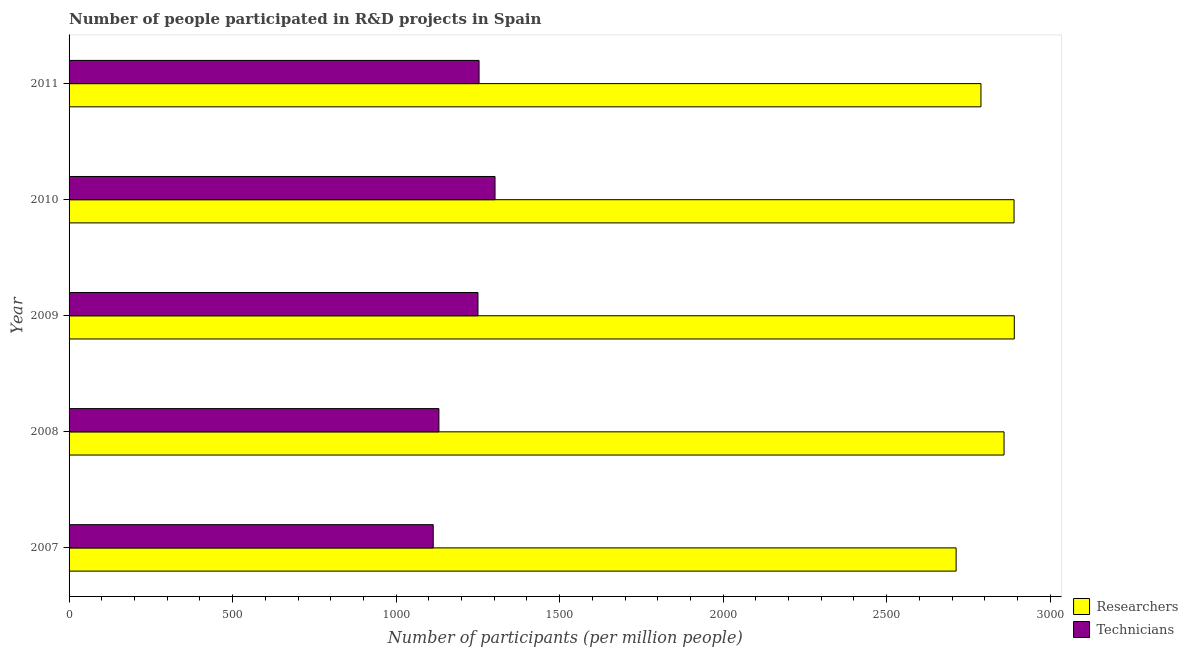Are the number of bars per tick equal to the number of legend labels?
Your response must be concise. Yes. What is the label of the 1st group of bars from the top?
Your answer should be compact. 2011. What is the number of technicians in 2011?
Your answer should be compact. 1253.62. Across all years, what is the maximum number of technicians?
Provide a succinct answer. 1302.46. Across all years, what is the minimum number of technicians?
Your response must be concise. 1113.5. What is the total number of researchers in the graph?
Provide a succinct answer. 1.41e+04. What is the difference between the number of researchers in 2008 and that in 2010?
Keep it short and to the point. -30.56. What is the difference between the number of researchers in 2009 and the number of technicians in 2007?
Ensure brevity in your answer.  1776.72. What is the average number of researchers per year?
Make the answer very short. 2827.84. In the year 2008, what is the difference between the number of researchers and number of technicians?
Offer a very short reply. 1728.05. In how many years, is the number of technicians greater than 1600 ?
Ensure brevity in your answer.  0. What is the ratio of the number of researchers in 2007 to that in 2010?
Your answer should be very brief. 0.94. Is the number of technicians in 2010 less than that in 2011?
Ensure brevity in your answer.  No. Is the difference between the number of researchers in 2007 and 2011 greater than the difference between the number of technicians in 2007 and 2011?
Keep it short and to the point. Yes. What is the difference between the highest and the second highest number of researchers?
Offer a terse response. 0.77. What is the difference between the highest and the lowest number of researchers?
Give a very brief answer. 177.87. Is the sum of the number of researchers in 2008 and 2009 greater than the maximum number of technicians across all years?
Give a very brief answer. Yes. What does the 2nd bar from the top in 2009 represents?
Your response must be concise. Researchers. What does the 2nd bar from the bottom in 2010 represents?
Give a very brief answer. Technicians. How many bars are there?
Your answer should be compact. 10. Are all the bars in the graph horizontal?
Provide a succinct answer. Yes. Are the values on the major ticks of X-axis written in scientific E-notation?
Offer a terse response. No. Does the graph contain any zero values?
Ensure brevity in your answer.  No. Does the graph contain grids?
Provide a short and direct response. No. What is the title of the graph?
Make the answer very short. Number of people participated in R&D projects in Spain. Does "Female" appear as one of the legend labels in the graph?
Keep it short and to the point. No. What is the label or title of the X-axis?
Give a very brief answer. Number of participants (per million people). What is the Number of participants (per million people) in Researchers in 2007?
Give a very brief answer. 2712.35. What is the Number of participants (per million people) of Technicians in 2007?
Provide a succinct answer. 1113.5. What is the Number of participants (per million people) in Researchers in 2008?
Give a very brief answer. 2858.9. What is the Number of participants (per million people) of Technicians in 2008?
Offer a very short reply. 1130.85. What is the Number of participants (per million people) of Researchers in 2009?
Offer a terse response. 2890.22. What is the Number of participants (per million people) in Technicians in 2009?
Your answer should be very brief. 1250.31. What is the Number of participants (per million people) in Researchers in 2010?
Provide a succinct answer. 2889.46. What is the Number of participants (per million people) of Technicians in 2010?
Keep it short and to the point. 1302.46. What is the Number of participants (per million people) in Researchers in 2011?
Make the answer very short. 2788.26. What is the Number of participants (per million people) in Technicians in 2011?
Offer a terse response. 1253.62. Across all years, what is the maximum Number of participants (per million people) in Researchers?
Your response must be concise. 2890.22. Across all years, what is the maximum Number of participants (per million people) of Technicians?
Offer a very short reply. 1302.46. Across all years, what is the minimum Number of participants (per million people) in Researchers?
Offer a very short reply. 2712.35. Across all years, what is the minimum Number of participants (per million people) in Technicians?
Your response must be concise. 1113.5. What is the total Number of participants (per million people) of Researchers in the graph?
Your answer should be compact. 1.41e+04. What is the total Number of participants (per million people) of Technicians in the graph?
Ensure brevity in your answer.  6050.74. What is the difference between the Number of participants (per million people) of Researchers in 2007 and that in 2008?
Make the answer very short. -146.55. What is the difference between the Number of participants (per million people) in Technicians in 2007 and that in 2008?
Your response must be concise. -17.35. What is the difference between the Number of participants (per million people) in Researchers in 2007 and that in 2009?
Offer a terse response. -177.87. What is the difference between the Number of participants (per million people) of Technicians in 2007 and that in 2009?
Your answer should be compact. -136.81. What is the difference between the Number of participants (per million people) of Researchers in 2007 and that in 2010?
Your answer should be very brief. -177.11. What is the difference between the Number of participants (per million people) of Technicians in 2007 and that in 2010?
Offer a very short reply. -188.96. What is the difference between the Number of participants (per million people) of Researchers in 2007 and that in 2011?
Offer a terse response. -75.91. What is the difference between the Number of participants (per million people) of Technicians in 2007 and that in 2011?
Your response must be concise. -140.12. What is the difference between the Number of participants (per million people) in Researchers in 2008 and that in 2009?
Keep it short and to the point. -31.32. What is the difference between the Number of participants (per million people) in Technicians in 2008 and that in 2009?
Your answer should be compact. -119.47. What is the difference between the Number of participants (per million people) of Researchers in 2008 and that in 2010?
Give a very brief answer. -30.56. What is the difference between the Number of participants (per million people) in Technicians in 2008 and that in 2010?
Make the answer very short. -171.61. What is the difference between the Number of participants (per million people) of Researchers in 2008 and that in 2011?
Your response must be concise. 70.64. What is the difference between the Number of participants (per million people) in Technicians in 2008 and that in 2011?
Offer a terse response. -122.77. What is the difference between the Number of participants (per million people) in Researchers in 2009 and that in 2010?
Ensure brevity in your answer.  0.77. What is the difference between the Number of participants (per million people) of Technicians in 2009 and that in 2010?
Your answer should be very brief. -52.15. What is the difference between the Number of participants (per million people) of Researchers in 2009 and that in 2011?
Your answer should be very brief. 101.97. What is the difference between the Number of participants (per million people) in Technicians in 2009 and that in 2011?
Your response must be concise. -3.31. What is the difference between the Number of participants (per million people) of Researchers in 2010 and that in 2011?
Your answer should be compact. 101.2. What is the difference between the Number of participants (per million people) in Technicians in 2010 and that in 2011?
Provide a succinct answer. 48.84. What is the difference between the Number of participants (per million people) of Researchers in 2007 and the Number of participants (per million people) of Technicians in 2008?
Ensure brevity in your answer.  1581.5. What is the difference between the Number of participants (per million people) of Researchers in 2007 and the Number of participants (per million people) of Technicians in 2009?
Ensure brevity in your answer.  1462.04. What is the difference between the Number of participants (per million people) in Researchers in 2007 and the Number of participants (per million people) in Technicians in 2010?
Provide a short and direct response. 1409.89. What is the difference between the Number of participants (per million people) of Researchers in 2007 and the Number of participants (per million people) of Technicians in 2011?
Ensure brevity in your answer.  1458.73. What is the difference between the Number of participants (per million people) in Researchers in 2008 and the Number of participants (per million people) in Technicians in 2009?
Your answer should be compact. 1608.59. What is the difference between the Number of participants (per million people) of Researchers in 2008 and the Number of participants (per million people) of Technicians in 2010?
Keep it short and to the point. 1556.44. What is the difference between the Number of participants (per million people) in Researchers in 2008 and the Number of participants (per million people) in Technicians in 2011?
Provide a short and direct response. 1605.28. What is the difference between the Number of participants (per million people) of Researchers in 2009 and the Number of participants (per million people) of Technicians in 2010?
Keep it short and to the point. 1587.76. What is the difference between the Number of participants (per million people) of Researchers in 2009 and the Number of participants (per million people) of Technicians in 2011?
Your answer should be very brief. 1636.6. What is the difference between the Number of participants (per million people) in Researchers in 2010 and the Number of participants (per million people) in Technicians in 2011?
Keep it short and to the point. 1635.84. What is the average Number of participants (per million people) of Researchers per year?
Provide a succinct answer. 2827.84. What is the average Number of participants (per million people) of Technicians per year?
Your answer should be compact. 1210.15. In the year 2007, what is the difference between the Number of participants (per million people) in Researchers and Number of participants (per million people) in Technicians?
Make the answer very short. 1598.85. In the year 2008, what is the difference between the Number of participants (per million people) in Researchers and Number of participants (per million people) in Technicians?
Provide a succinct answer. 1728.05. In the year 2009, what is the difference between the Number of participants (per million people) in Researchers and Number of participants (per million people) in Technicians?
Provide a succinct answer. 1639.91. In the year 2010, what is the difference between the Number of participants (per million people) in Researchers and Number of participants (per million people) in Technicians?
Your answer should be compact. 1587. In the year 2011, what is the difference between the Number of participants (per million people) of Researchers and Number of participants (per million people) of Technicians?
Your answer should be very brief. 1534.64. What is the ratio of the Number of participants (per million people) of Researchers in 2007 to that in 2008?
Offer a terse response. 0.95. What is the ratio of the Number of participants (per million people) of Technicians in 2007 to that in 2008?
Your answer should be compact. 0.98. What is the ratio of the Number of participants (per million people) of Researchers in 2007 to that in 2009?
Provide a short and direct response. 0.94. What is the ratio of the Number of participants (per million people) in Technicians in 2007 to that in 2009?
Give a very brief answer. 0.89. What is the ratio of the Number of participants (per million people) of Researchers in 2007 to that in 2010?
Your answer should be compact. 0.94. What is the ratio of the Number of participants (per million people) in Technicians in 2007 to that in 2010?
Ensure brevity in your answer.  0.85. What is the ratio of the Number of participants (per million people) of Researchers in 2007 to that in 2011?
Provide a succinct answer. 0.97. What is the ratio of the Number of participants (per million people) in Technicians in 2007 to that in 2011?
Offer a terse response. 0.89. What is the ratio of the Number of participants (per million people) of Technicians in 2008 to that in 2009?
Your response must be concise. 0.9. What is the ratio of the Number of participants (per million people) of Researchers in 2008 to that in 2010?
Provide a succinct answer. 0.99. What is the ratio of the Number of participants (per million people) in Technicians in 2008 to that in 2010?
Your answer should be compact. 0.87. What is the ratio of the Number of participants (per million people) of Researchers in 2008 to that in 2011?
Offer a very short reply. 1.03. What is the ratio of the Number of participants (per million people) in Technicians in 2008 to that in 2011?
Make the answer very short. 0.9. What is the ratio of the Number of participants (per million people) in Researchers in 2009 to that in 2010?
Your response must be concise. 1. What is the ratio of the Number of participants (per million people) in Technicians in 2009 to that in 2010?
Your response must be concise. 0.96. What is the ratio of the Number of participants (per million people) in Researchers in 2009 to that in 2011?
Your response must be concise. 1.04. What is the ratio of the Number of participants (per million people) in Researchers in 2010 to that in 2011?
Keep it short and to the point. 1.04. What is the ratio of the Number of participants (per million people) of Technicians in 2010 to that in 2011?
Provide a short and direct response. 1.04. What is the difference between the highest and the second highest Number of participants (per million people) of Researchers?
Your answer should be compact. 0.77. What is the difference between the highest and the second highest Number of participants (per million people) of Technicians?
Your answer should be compact. 48.84. What is the difference between the highest and the lowest Number of participants (per million people) of Researchers?
Offer a terse response. 177.87. What is the difference between the highest and the lowest Number of participants (per million people) in Technicians?
Ensure brevity in your answer.  188.96. 